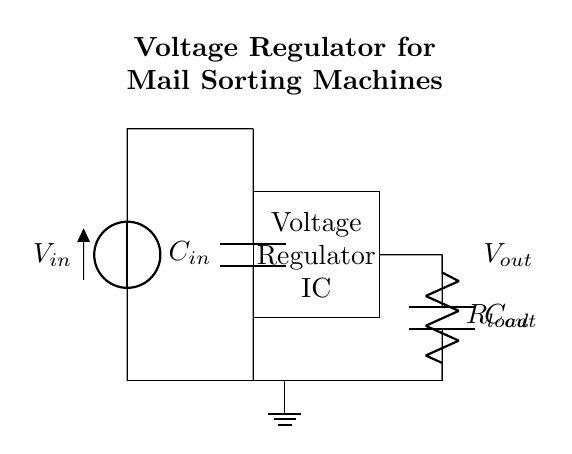what is the input component in this circuit? The input component is a voltage source labeled as Vin. This is identified at the left side of the diagram where the voltage source symbol is drawn.
Answer: Vin what type of component is used for filtering at the input? The filter component used at the input is a capacitor labeled as Cin. This can be seen connected in parallel to the input voltage source, indicating its role in smoothing out voltage fluctuations.
Answer: Cin what is the purpose of the voltage regulator IC? The voltage regulator IC maintains a stable output voltage despite variations in input voltage or load current. It is clearly labeled in the diagram, and its position indicates that it takes the input voltage and regulates it to provide a consistent output.
Answer: Stable output voltage what is the output load in this circuit? The output load is represented by a resistor labeled as Rload. It is connected to the output of the voltage regulator and is used to represent the mail sorting machines' power requirement.
Answer: Rload how many capacitors are present in the circuit? There are two capacitors present in the circuit, labeled as Cin and Cout. They are identified in the circuit diagram: one at the input and one at the output, both serving different functions in voltage regulation.
Answer: Two what happens to the output voltage if the input voltage varies widely? If the input voltage varies widely, the voltage regulator IC will adjust to maintain a constant output voltage, ensuring that the voltage supplied to the load remains stable. This is the primary function of the voltage regulator, as indicated in the design of the circuit.
Answer: Output remains stable what isolating component is used to ground in this circuit? The isolating component used for grounding is labeled as ground in the diagram. This indicates that the circuit has a reference point at zero voltage, essential for the proper functioning of electrical components and is crucial for safety.
Answer: Ground 